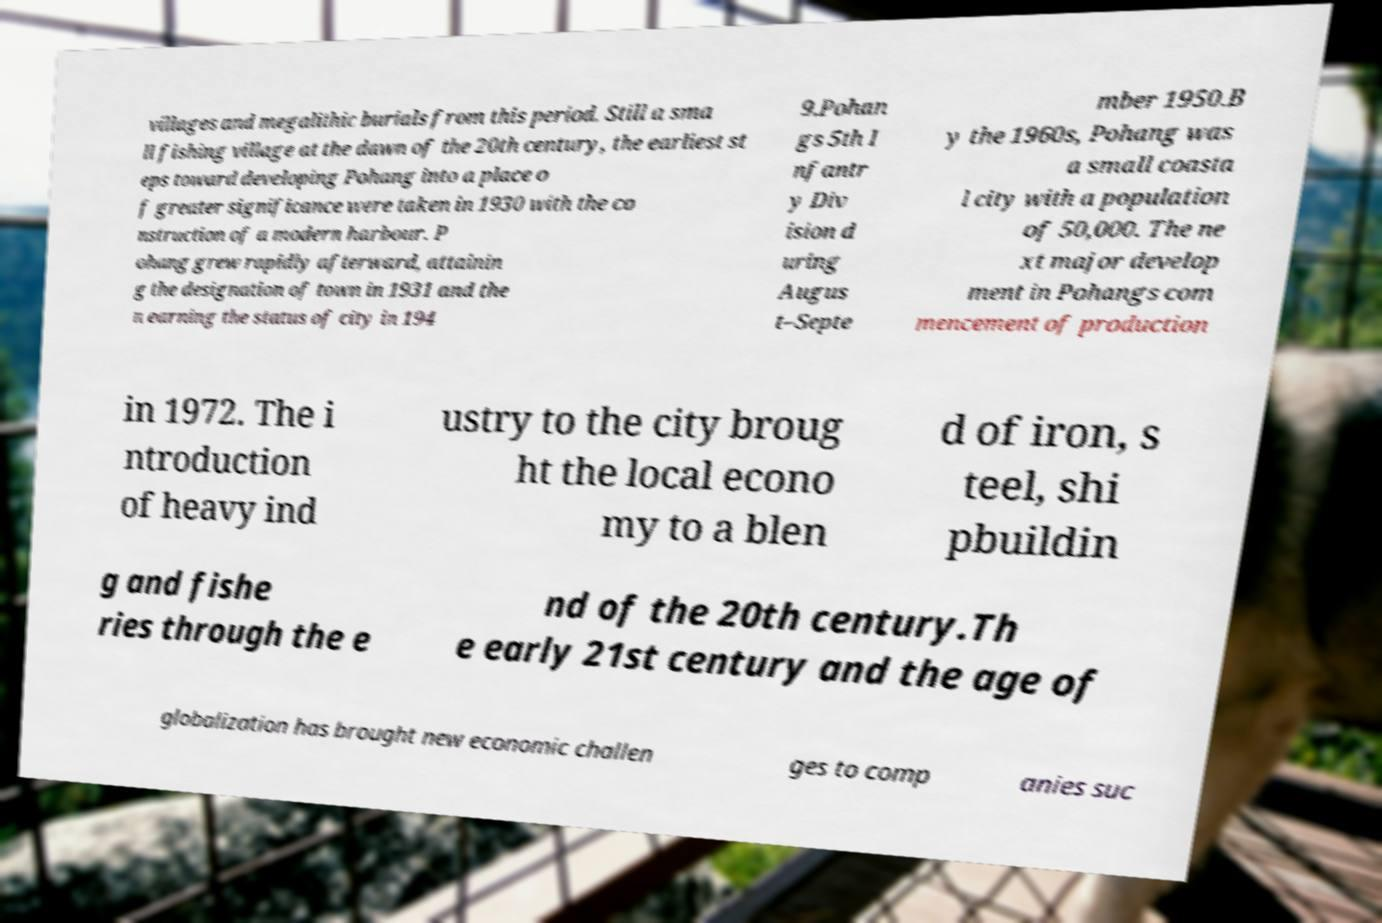Please read and relay the text visible in this image. What does it say? villages and megalithic burials from this period. Still a sma ll fishing village at the dawn of the 20th century, the earliest st eps toward developing Pohang into a place o f greater significance were taken in 1930 with the co nstruction of a modern harbour. P ohang grew rapidly afterward, attainin g the designation of town in 1931 and the n earning the status of city in 194 9.Pohan gs 5th I nfantr y Div ision d uring Augus t–Septe mber 1950.B y the 1960s, Pohang was a small coasta l city with a population of 50,000. The ne xt major develop ment in Pohangs com mencement of production in 1972. The i ntroduction of heavy ind ustry to the city broug ht the local econo my to a blen d of iron, s teel, shi pbuildin g and fishe ries through the e nd of the 20th century.Th e early 21st century and the age of globalization has brought new economic challen ges to comp anies suc 